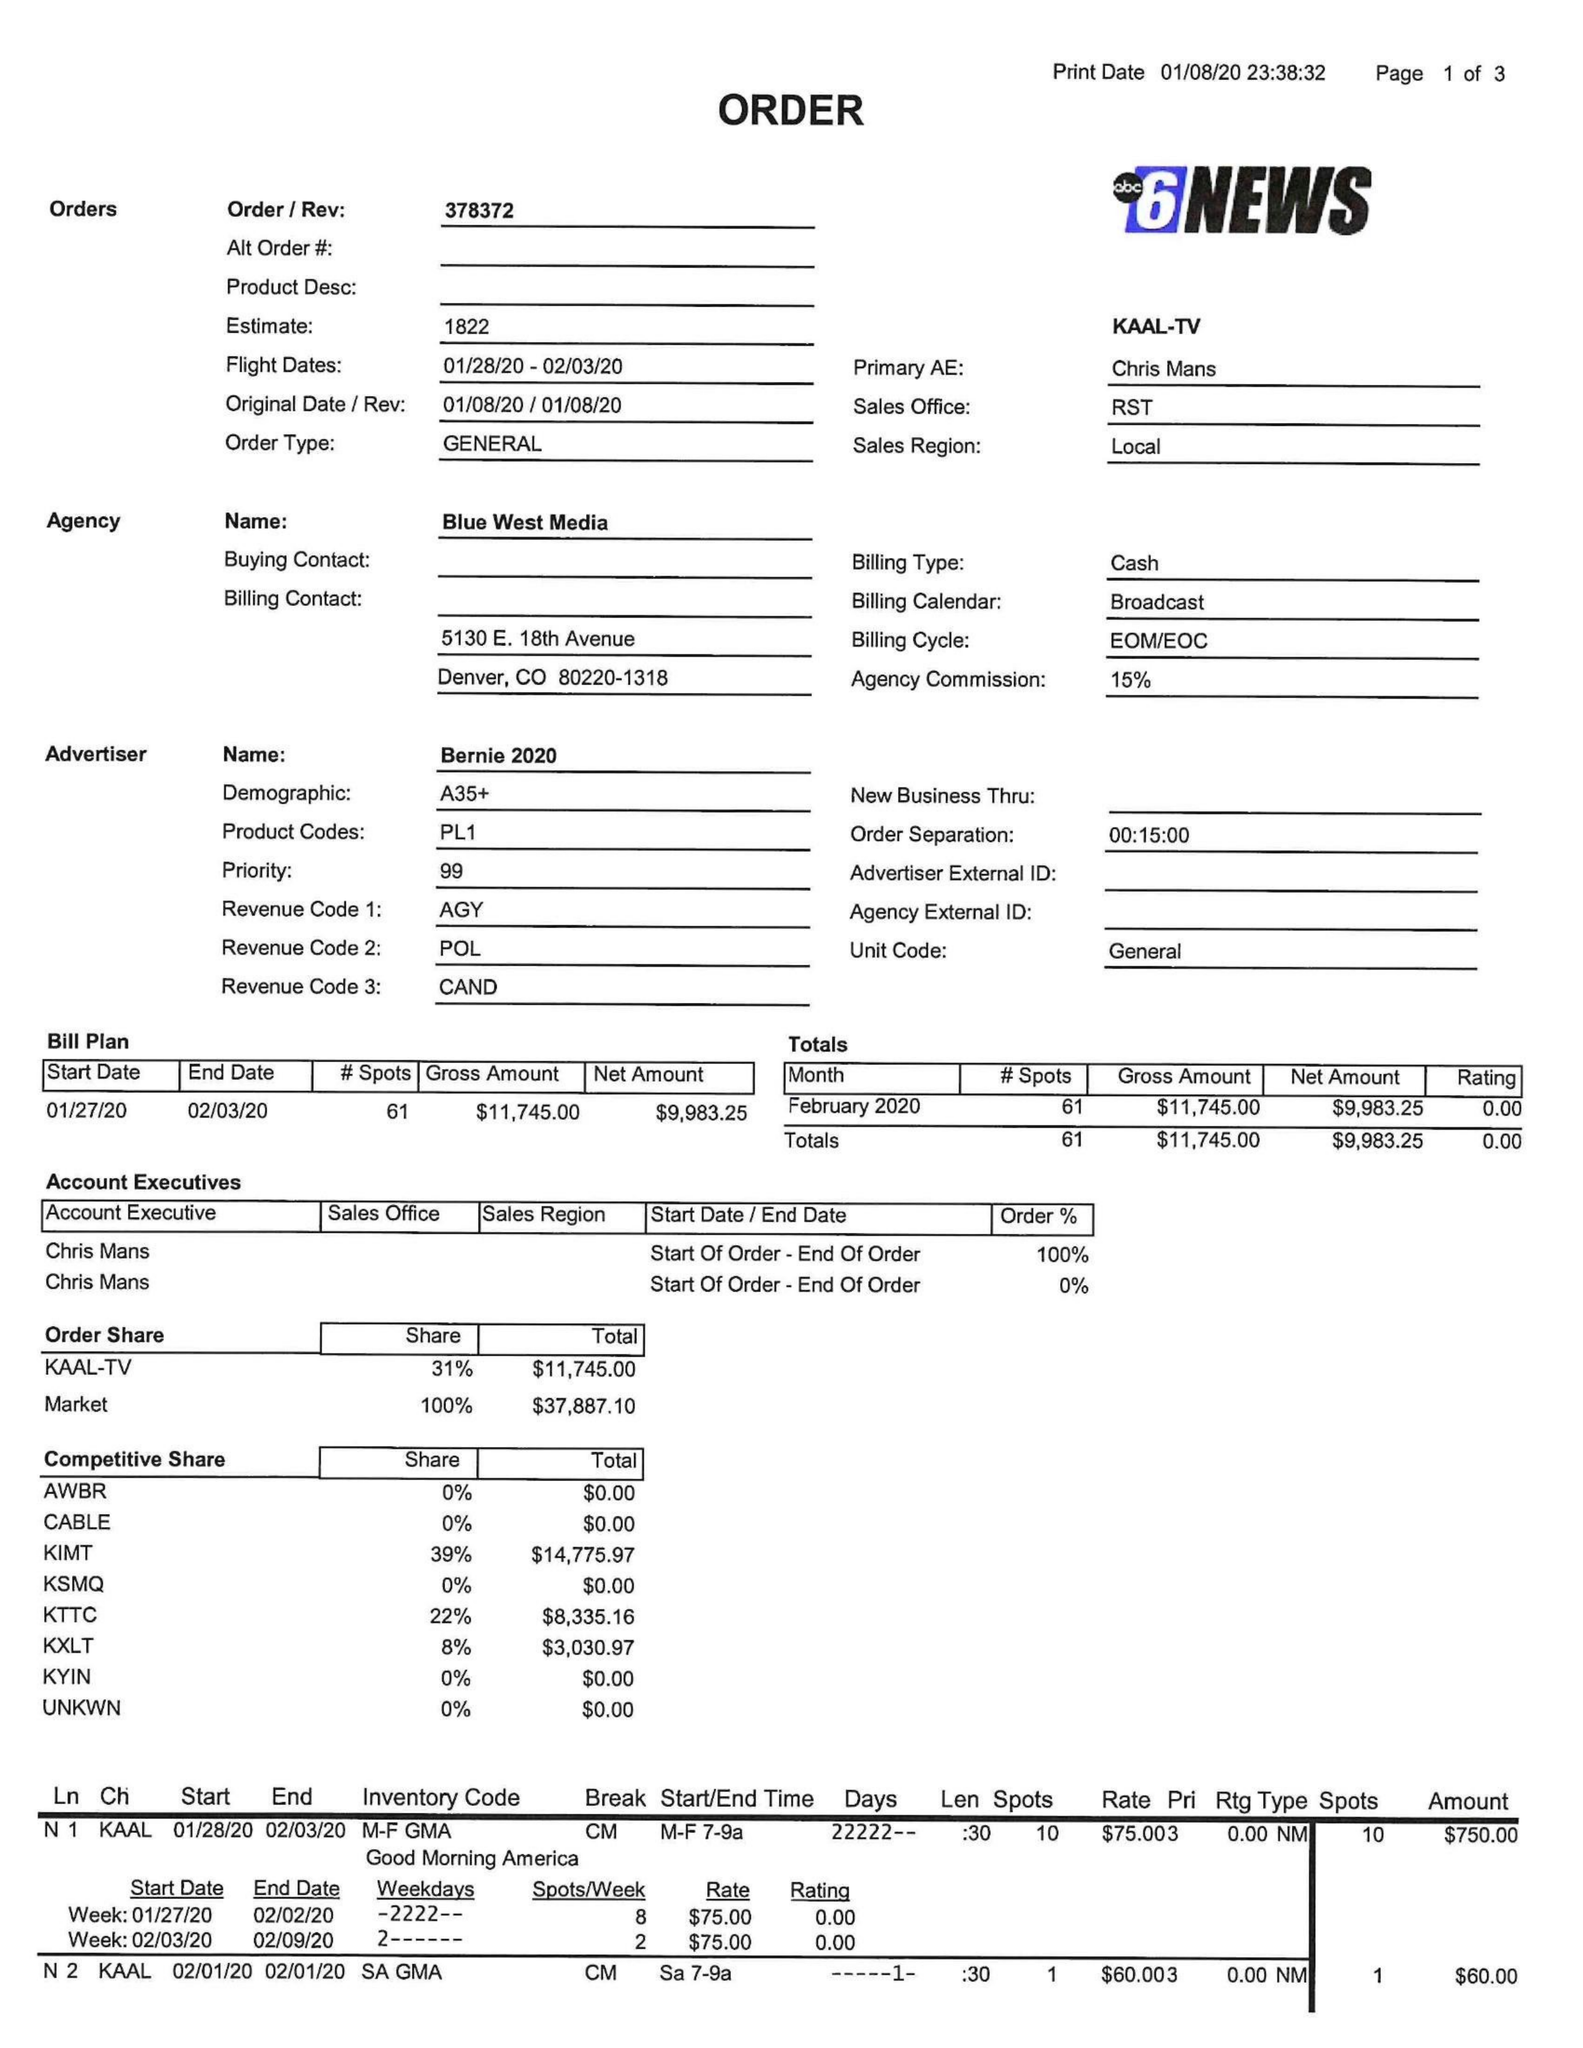What is the value for the gross_amount?
Answer the question using a single word or phrase. 11745.00 